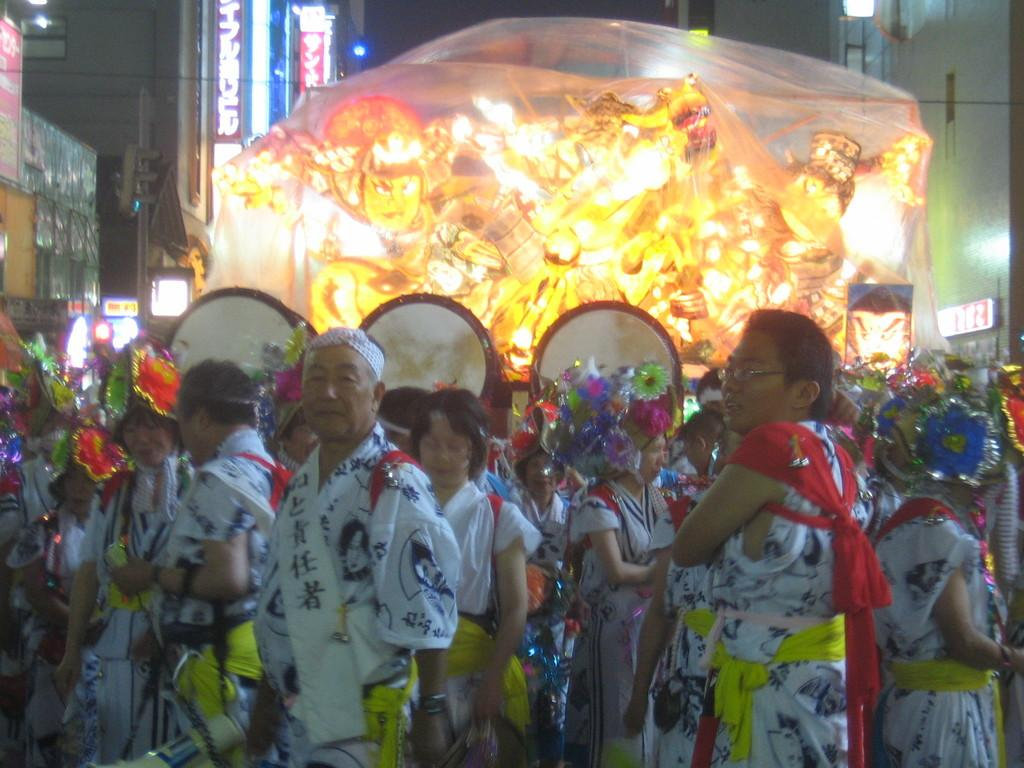How many people are in the image? There is a group of people in the image. What are the people in the image doing? The people are standing. What can be seen in the background of the image? There are buildings, hoardings, lights, and a pole in the background of the image. How many daughters does the person in the center of the image have? There is no information about the number of daughters or any specific person in the image. How many frogs can be seen on the pole in the background? There are no frogs present in the image. 